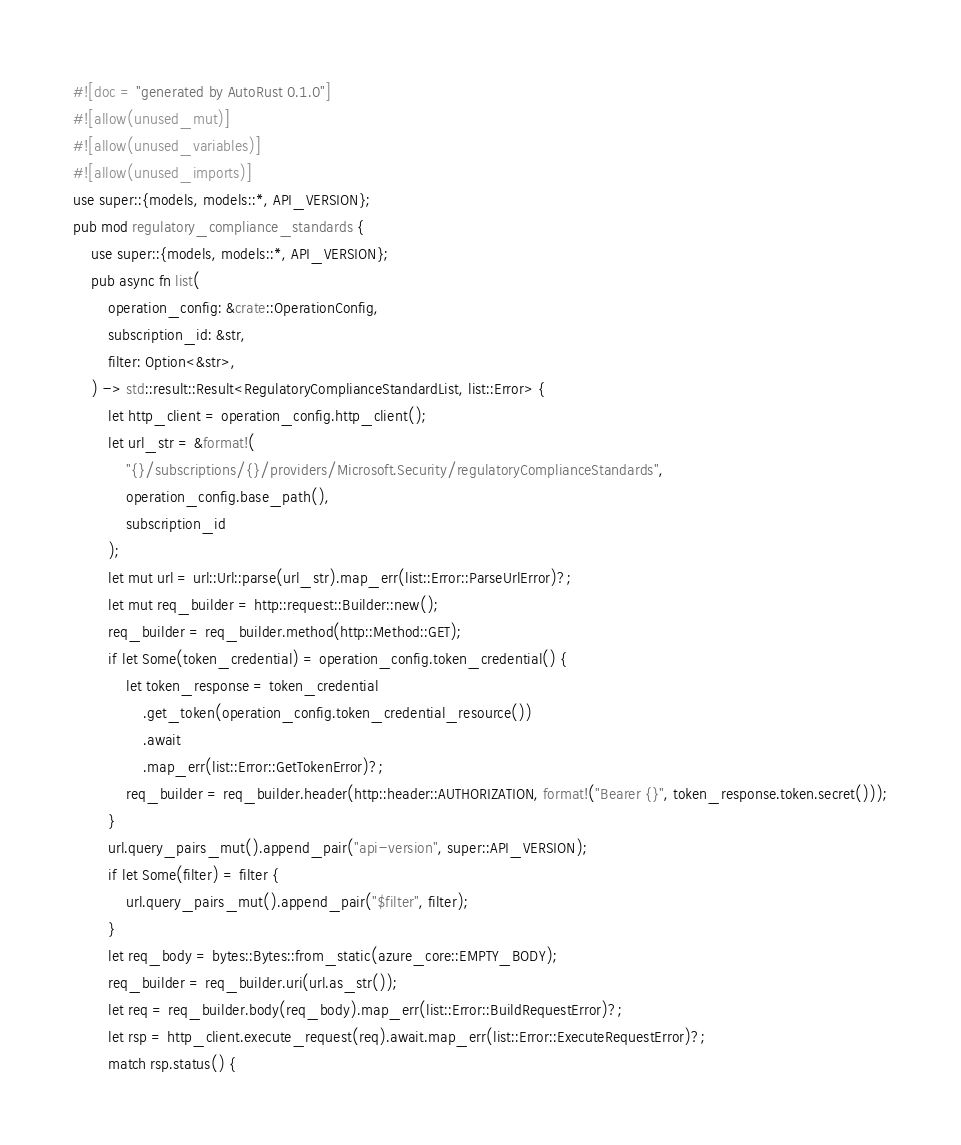Convert code to text. <code><loc_0><loc_0><loc_500><loc_500><_Rust_>#![doc = "generated by AutoRust 0.1.0"]
#![allow(unused_mut)]
#![allow(unused_variables)]
#![allow(unused_imports)]
use super::{models, models::*, API_VERSION};
pub mod regulatory_compliance_standards {
    use super::{models, models::*, API_VERSION};
    pub async fn list(
        operation_config: &crate::OperationConfig,
        subscription_id: &str,
        filter: Option<&str>,
    ) -> std::result::Result<RegulatoryComplianceStandardList, list::Error> {
        let http_client = operation_config.http_client();
        let url_str = &format!(
            "{}/subscriptions/{}/providers/Microsoft.Security/regulatoryComplianceStandards",
            operation_config.base_path(),
            subscription_id
        );
        let mut url = url::Url::parse(url_str).map_err(list::Error::ParseUrlError)?;
        let mut req_builder = http::request::Builder::new();
        req_builder = req_builder.method(http::Method::GET);
        if let Some(token_credential) = operation_config.token_credential() {
            let token_response = token_credential
                .get_token(operation_config.token_credential_resource())
                .await
                .map_err(list::Error::GetTokenError)?;
            req_builder = req_builder.header(http::header::AUTHORIZATION, format!("Bearer {}", token_response.token.secret()));
        }
        url.query_pairs_mut().append_pair("api-version", super::API_VERSION);
        if let Some(filter) = filter {
            url.query_pairs_mut().append_pair("$filter", filter);
        }
        let req_body = bytes::Bytes::from_static(azure_core::EMPTY_BODY);
        req_builder = req_builder.uri(url.as_str());
        let req = req_builder.body(req_body).map_err(list::Error::BuildRequestError)?;
        let rsp = http_client.execute_request(req).await.map_err(list::Error::ExecuteRequestError)?;
        match rsp.status() {</code> 